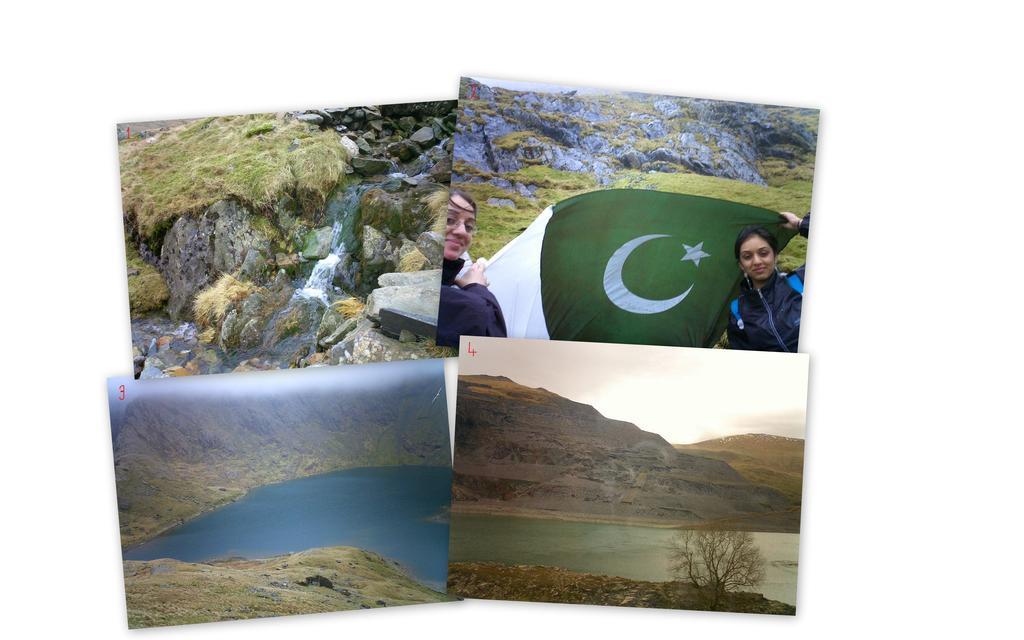In one or two sentences, can you explain what this image depicts? In this image we can see a collage picture. In the collage picture there are waterfall, stones, rocks, woman holding a flag, hills, lakes and trees. 